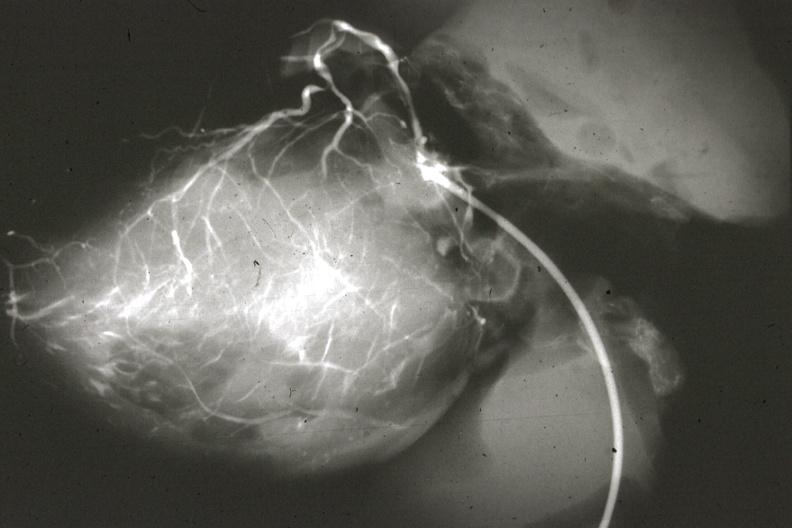where is this from?
Answer the question using a single word or phrase. Heart 